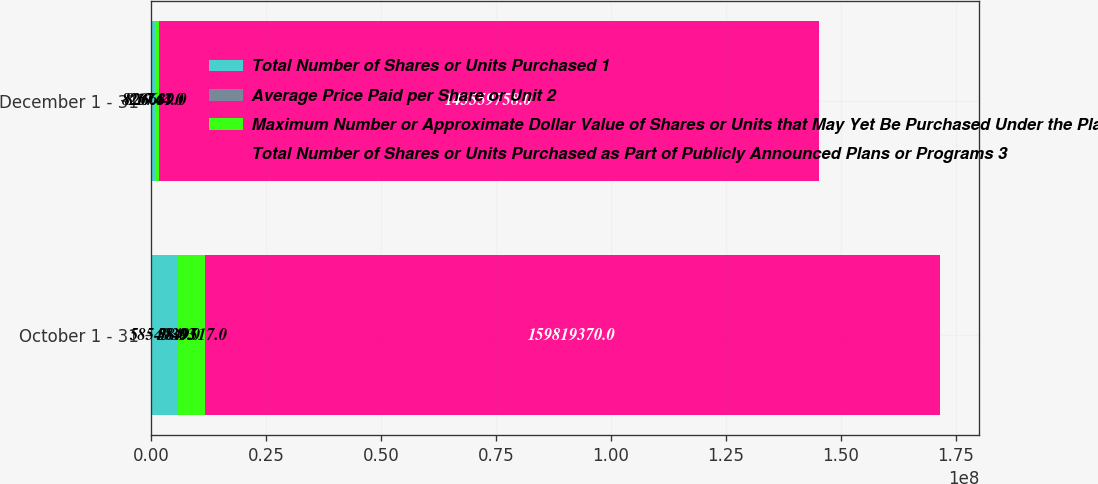Convert chart to OTSL. <chart><loc_0><loc_0><loc_500><loc_500><stacked_bar_chart><ecel><fcel>October 1 - 31<fcel>December 1 - 31<nl><fcel>Total Number of Shares or Units Purchased 1<fcel>5.85493e+06<fcel>826744<nl><fcel>Average Price Paid per Share or Unit 2<fcel>18.93<fcel>19.67<nl><fcel>Maximum Number or Approximate Dollar Value of Shares or Units that May Yet Be Purchased Under the Plans or Programs 3<fcel>5.84952e+06<fcel>826639<nl><fcel>Total Number of Shares or Units Purchased as Part of Publicly Announced Plans or Programs 3<fcel>1.59819e+08<fcel>1.4356e+08<nl></chart> 